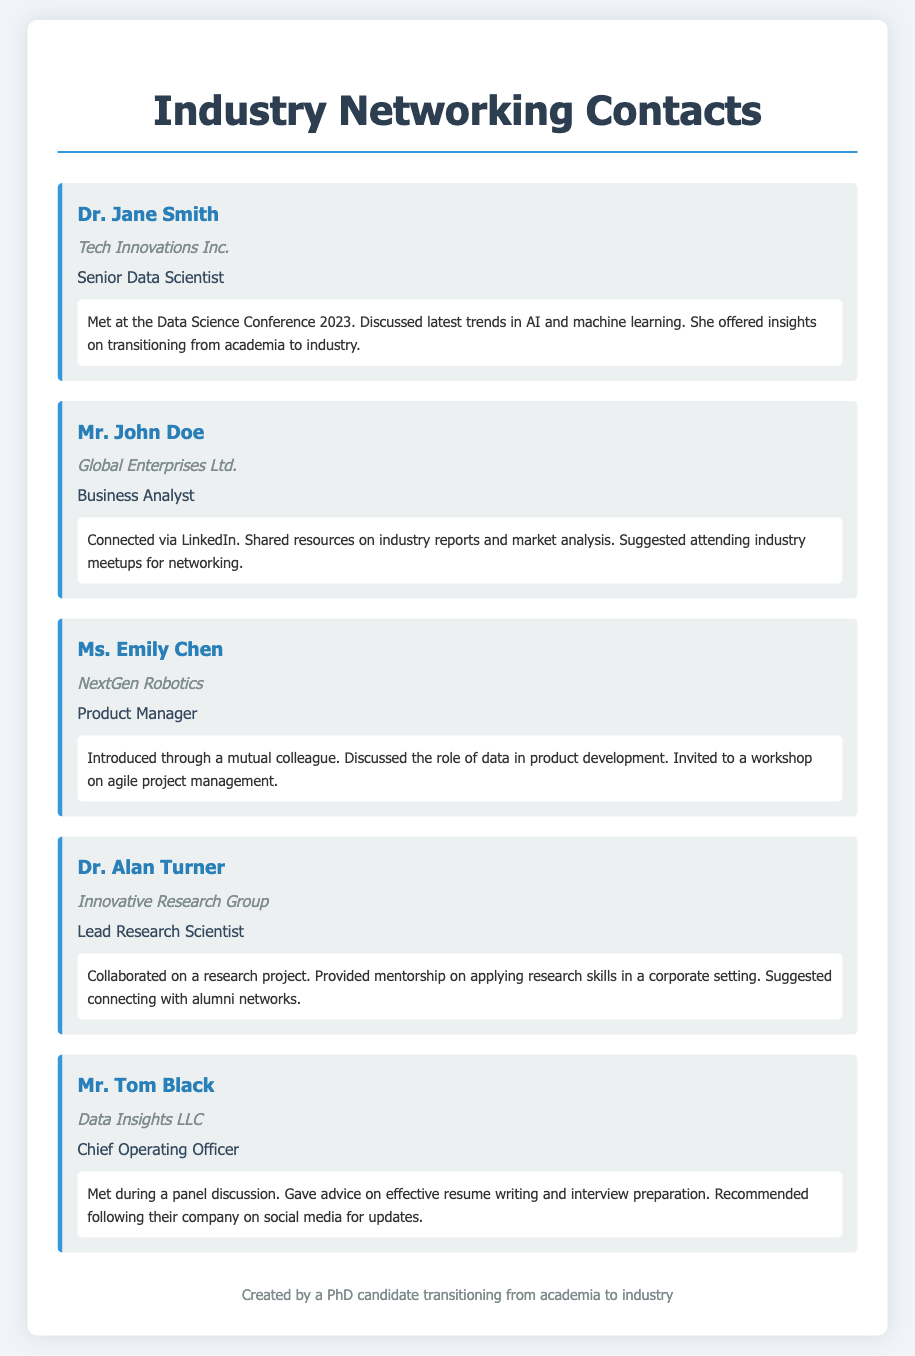What is the name of the Senior Data Scientist? The document states that Dr. Jane Smith is the Senior Data Scientist.
Answer: Dr. Jane Smith Which company does Mr. John Doe work for? The document indicates that Mr. John Doe is associated with Global Enterprises Ltd.
Answer: Global Enterprises Ltd What role does Ms. Emily Chen hold? As per the document, Ms. Emily Chen is the Product Manager.
Answer: Product Manager How did the author connect with Dr. Alan Turner? It is noted that the author collaborated on a research project with Dr. Alan Turner.
Answer: Collaborated on a research project What advice did Mr. Tom Black give regarding job applications? The document mentions that Mr. Tom Black provided advice on effective resume writing.
Answer: Effective resume writing What type of event did Dr. Jane Smith and the author meet at? According to the document, the meeting occurred at the Data Science Conference 2023.
Answer: Data Science Conference 2023 Which professional role offered insights on transitioning from academia to industry? The document indicates that Dr. Jane Smith provided insights on this topic.
Answer: Dr. Jane Smith What was a common theme in interactions with networking contacts? Many contacts provided advice or mentorship regarding industry transition and networking strategies.
Answer: Advice on industry transition and networking strategies 